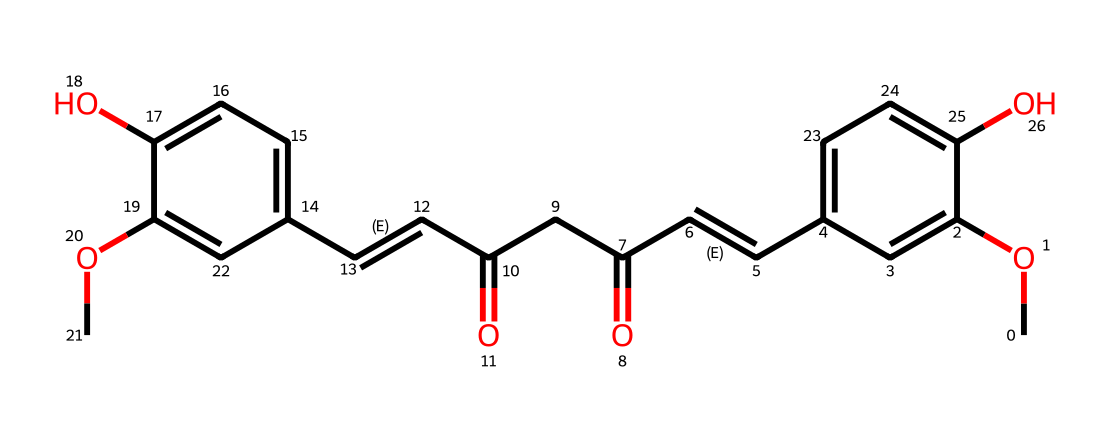What is the main functional group present in curcumin? The molecular structure contains hydroxyl groups (-OH) attached to the aromatic rings, which indicates they are the main functional groups.
Answer: hydroxyl How many distinct aromatic rings are present in the structure of curcumin? By analyzing the structure, there are two distinct aromatic rings visible in the SMILES representation, indicated by the notation for the cyclic carbon atoms.
Answer: two What is the oxidation state of the carbon in the carbonyl group (C=O) in curcumin? The carbon in the carbonyl group (C=O) is in the oxidation state of +2 because carbon is bonded to two oxygen atoms, one with a double bond (higher electronegativity) and one with a potential single bond in another context.
Answer: +2 How many double bonds can be found in the structure of curcumin? The SMILES representation shows two double bonds within the alkene segments, which is typical for its structure containing conjugated systems.
Answer: two What type of lipid does curcumin belong to? Curcumin is classified as a phenolic lipid, characterized by its hydrophobic tail and hydrophilic phenolic head due to the presence of hydroxyl groups.
Answer: phenolic lipid 